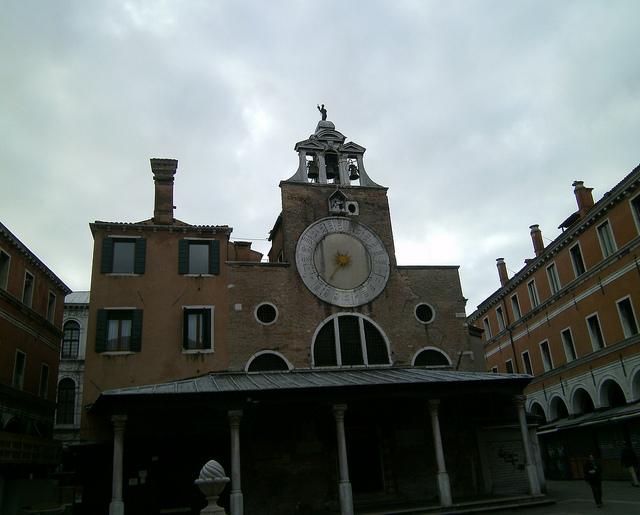What number of windows are on the building?
Give a very brief answer. 9. What is covering the building?
Keep it brief. Bricks. Is it cloudy?
Answer briefly. Yes. What is the big round thing on the building?
Short answer required. Clock. What color are the hands on the clock?
Keep it brief. Gold. Is that a clock?
Give a very brief answer. Yes. How many clock faces?
Be succinct. 1. Where is the clock?
Short answer required. On building. Does someone want to steal that gold dial?
Keep it brief. No. Is this a sunny day?
Be succinct. No. What time is it?
Quick response, please. 6:35. Are there any people nearby?
Quick response, please. Yes. How many clocks are there?
Concise answer only. 1. Is the building fancy or rustic?
Write a very short answer. Rustic. What type of architecture is this?
Write a very short answer. Victorian. Is the building tall?
Answer briefly. No. Is the street light sitting below the clock tower?
Short answer required. No. 